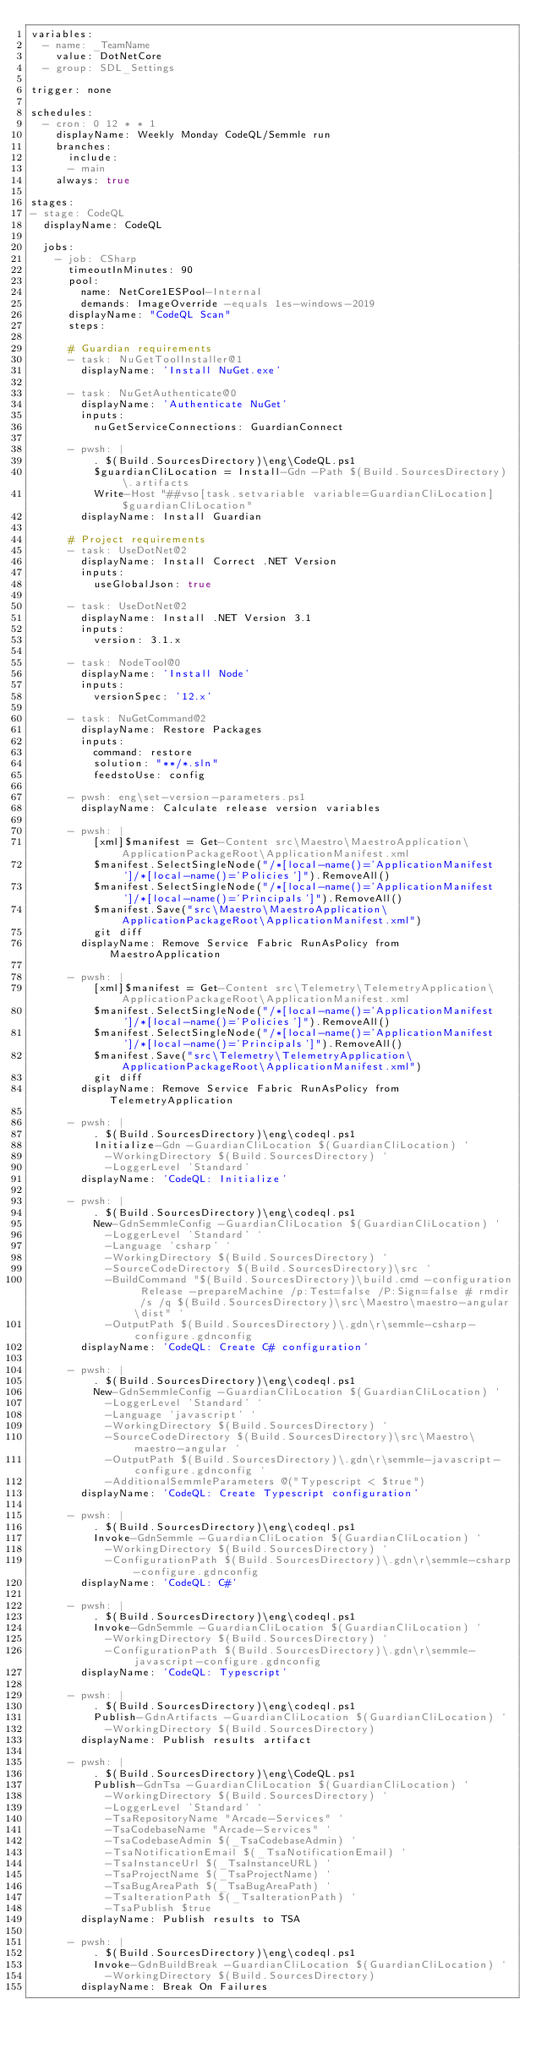<code> <loc_0><loc_0><loc_500><loc_500><_YAML_>variables:
  - name: _TeamName
    value: DotNetCore
  - group: SDL_Settings

trigger: none

schedules:
  - cron: 0 12 * * 1
    displayName: Weekly Monday CodeQL/Semmle run
    branches:
      include:
      - main
    always: true

stages:
- stage: CodeQL
  displayName: CodeQL

  jobs:
    - job: CSharp
      timeoutInMinutes: 90
      pool: 
        name: NetCore1ESPool-Internal
        demands: ImageOverride -equals 1es-windows-2019
      displayName: "CodeQL Scan"
      steps:

      # Guardian requirements
      - task: NuGetToolInstaller@1
        displayName: 'Install NuGet.exe'

      - task: NuGetAuthenticate@0
        displayName: 'Authenticate NuGet'
        inputs:
          nuGetServiceConnections: GuardianConnect
  
      - pwsh: |
          . $(Build.SourcesDirectory)\eng\CodeQL.ps1
          $guardianCliLocation = Install-Gdn -Path $(Build.SourcesDirectory)\.artifacts
          Write-Host "##vso[task.setvariable variable=GuardianCliLocation]$guardianCliLocation"
        displayName: Install Guardian

      # Project requirements
      - task: UseDotNet@2
        displayName: Install Correct .NET Version
        inputs:
          useGlobalJson: true

      - task: UseDotNet@2
        displayName: Install .NET Version 3.1
        inputs:
          version: 3.1.x

      - task: NodeTool@0
        displayName: 'Install Node'
        inputs:
          versionSpec: '12.x'

      - task: NuGetCommand@2
        displayName: Restore Packages
        inputs:
          command: restore
          solution: "**/*.sln"
          feedstoUse: config

      - pwsh: eng\set-version-parameters.ps1
        displayName: Calculate release version variables
        
      - pwsh: |
          [xml]$manifest = Get-Content src\Maestro\MaestroApplication\ApplicationPackageRoot\ApplicationManifest.xml
          $manifest.SelectSingleNode("/*[local-name()='ApplicationManifest']/*[local-name()='Policies']").RemoveAll()
          $manifest.SelectSingleNode("/*[local-name()='ApplicationManifest']/*[local-name()='Principals']").RemoveAll()
          $manifest.Save("src\Maestro\MaestroApplication\ApplicationPackageRoot\ApplicationManifest.xml")
          git diff
        displayName: Remove Service Fabric RunAsPolicy from MaestroApplication

      - pwsh: |
          [xml]$manifest = Get-Content src\Telemetry\TelemetryApplication\ApplicationPackageRoot\ApplicationManifest.xml
          $manifest.SelectSingleNode("/*[local-name()='ApplicationManifest']/*[local-name()='Policies']").RemoveAll()
          $manifest.SelectSingleNode("/*[local-name()='ApplicationManifest']/*[local-name()='Principals']").RemoveAll()
          $manifest.Save("src\Telemetry\TelemetryApplication\ApplicationPackageRoot\ApplicationManifest.xml")
          git diff
        displayName: Remove Service Fabric RunAsPolicy from TelemetryApplication
      
      - pwsh: |
          . $(Build.SourcesDirectory)\eng\codeql.ps1
          Initialize-Gdn -GuardianCliLocation $(GuardianCliLocation) `
            -WorkingDirectory $(Build.SourcesDirectory) `
            -LoggerLevel 'Standard'
        displayName: 'CodeQL: Initialize'

      - pwsh: |
          . $(Build.SourcesDirectory)\eng\codeql.ps1
          New-GdnSemmleConfig -GuardianCliLocation $(GuardianCliLocation) `
            -LoggerLevel 'Standard' `
            -Language 'csharp' `
            -WorkingDirectory $(Build.SourcesDirectory) `
            -SourceCodeDirectory $(Build.SourcesDirectory)\src `
            -BuildCommand "$(Build.SourcesDirectory)\build.cmd -configuration Release -prepareMachine /p:Test=false /P:Sign=false # rmdir /s /q $(Build.SourcesDirectory)\src\Maestro\maestro-angular\dist" `
            -OutputPath $(Build.SourcesDirectory)\.gdn\r\semmle-csharp-configure.gdnconfig
        displayName: 'CodeQL: Create C# configuration'

      - pwsh: |
          . $(Build.SourcesDirectory)\eng\codeql.ps1
          New-GdnSemmleConfig -GuardianCliLocation $(GuardianCliLocation) `
            -LoggerLevel 'Standard' `
            -Language 'javascript' `
            -WorkingDirectory $(Build.SourcesDirectory) `
            -SourceCodeDirectory $(Build.SourcesDirectory)\src\Maestro\maestro-angular `
            -OutputPath $(Build.SourcesDirectory)\.gdn\r\semmle-javascript-configure.gdnconfig `
            -AdditionalSemmleParameters @("Typescript < $true")
        displayName: 'CodeQL: Create Typescript configuration'

      - pwsh: |
          . $(Build.SourcesDirectory)\eng\codeql.ps1
          Invoke-GdnSemmle -GuardianCliLocation $(GuardianCliLocation) `
            -WorkingDirectory $(Build.SourcesDirectory) `
            -ConfigurationPath $(Build.SourcesDirectory)\.gdn\r\semmle-csharp-configure.gdnconfig
        displayName: 'CodeQL: C#'

      - pwsh: |
          . $(Build.SourcesDirectory)\eng\codeql.ps1
          Invoke-GdnSemmle -GuardianCliLocation $(GuardianCliLocation) `
            -WorkingDirectory $(Build.SourcesDirectory) `
            -ConfigurationPath $(Build.SourcesDirectory)\.gdn\r\semmle-javascript-configure.gdnconfig
        displayName: 'CodeQL: Typescript'

      - pwsh: |
          . $(Build.SourcesDirectory)\eng\codeql.ps1
          Publish-GdnArtifacts -GuardianCliLocation $(GuardianCliLocation) `
            -WorkingDirectory $(Build.SourcesDirectory)
        displayName: Publish results artifact

      - pwsh: |
          . $(Build.SourcesDirectory)\eng\CodeQL.ps1
          Publish-GdnTsa -GuardianCliLocation $(GuardianCliLocation) `
            -WorkingDirectory $(Build.SourcesDirectory) `
            -LoggerLevel 'Standard' `
            -TsaRepositoryName "Arcade-Services" `
            -TsaCodebaseName "Arcade-Services" `
            -TsaCodebaseAdmin $(_TsaCodebaseAdmin) `
            -TsaNotificationEmail $(_TsaNotificationEmail) `
            -TsaInstanceUrl $(_TsaInstanceURL) `
            -TsaProjectName $(_TsaProjectName) `
            -TsaBugAreaPath $(_TsaBugAreaPath) `
            -TsaIterationPath $(_TsaIterationPath) `
            -TsaPublish $true
        displayName: Publish results to TSA

      - pwsh: |
          . $(Build.SourcesDirectory)\eng\codeql.ps1
          Invoke-GdnBuildBreak -GuardianCliLocation $(GuardianCliLocation) `
            -WorkingDirectory $(Build.SourcesDirectory)
        displayName: Break On Failures
</code> 